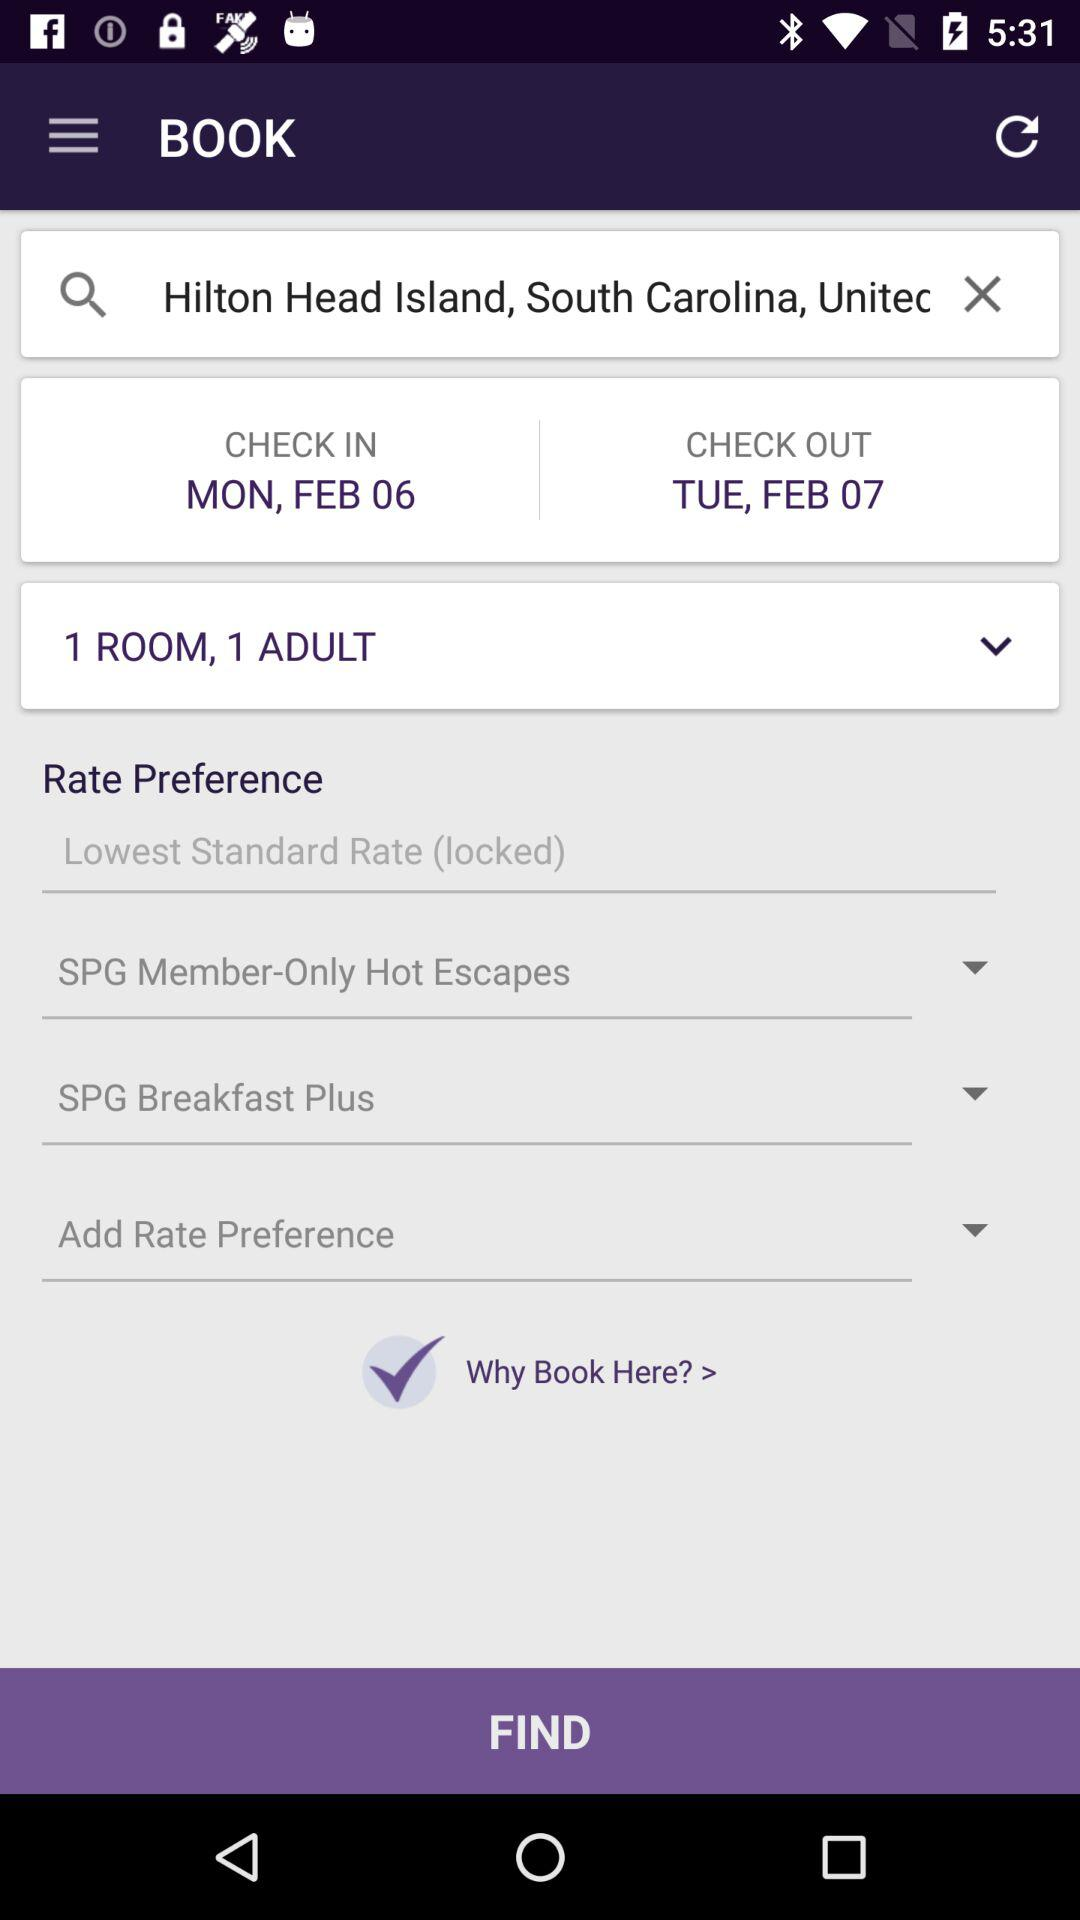What's the address of the hotel?
When the provided information is insufficient, respond with <no answer>. <no answer> 